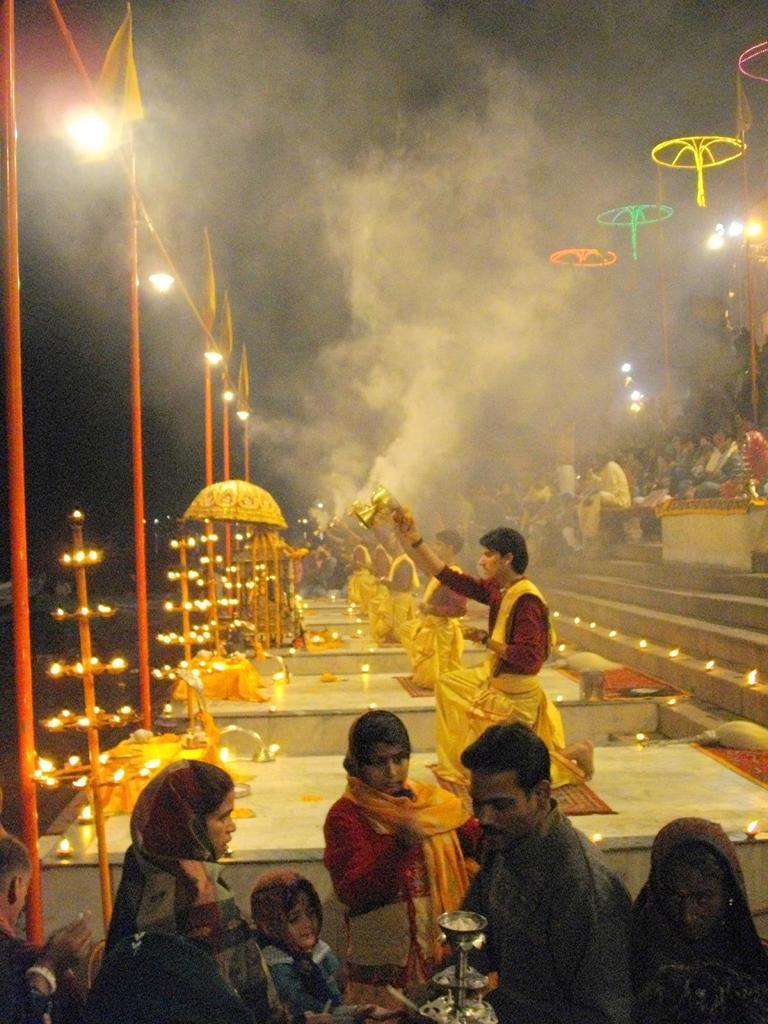Could you give a brief overview of what you see in this image? In this image at the bottom there are a group of people, at the bottom there are some people who are holding something and it seems that they are praying. In front of them there are diyas, poles, flags and some flowers and some objects. And on the right side of the image there are some people who are sitting on stairs, and there are some diyas, lights and some dog is coming out and at the top there is sky. 